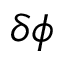<formula> <loc_0><loc_0><loc_500><loc_500>\delta \phi</formula> 